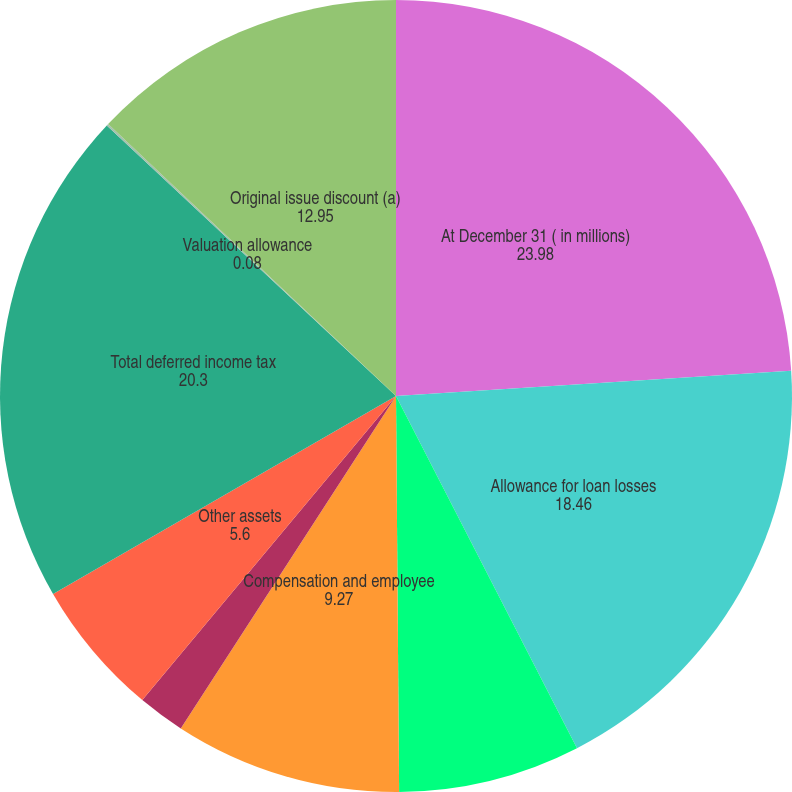Convert chart. <chart><loc_0><loc_0><loc_500><loc_500><pie_chart><fcel>At December 31 ( in millions)<fcel>Allowance for loan losses<fcel>Reward programs<fcel>Compensation and employee<fcel>Net operating losses<fcel>Other assets<fcel>Total deferred income tax<fcel>Valuation allowance<fcel>Original issue discount (a)<nl><fcel>23.98%<fcel>18.46%<fcel>7.43%<fcel>9.27%<fcel>1.92%<fcel>5.6%<fcel>20.3%<fcel>0.08%<fcel>12.95%<nl></chart> 